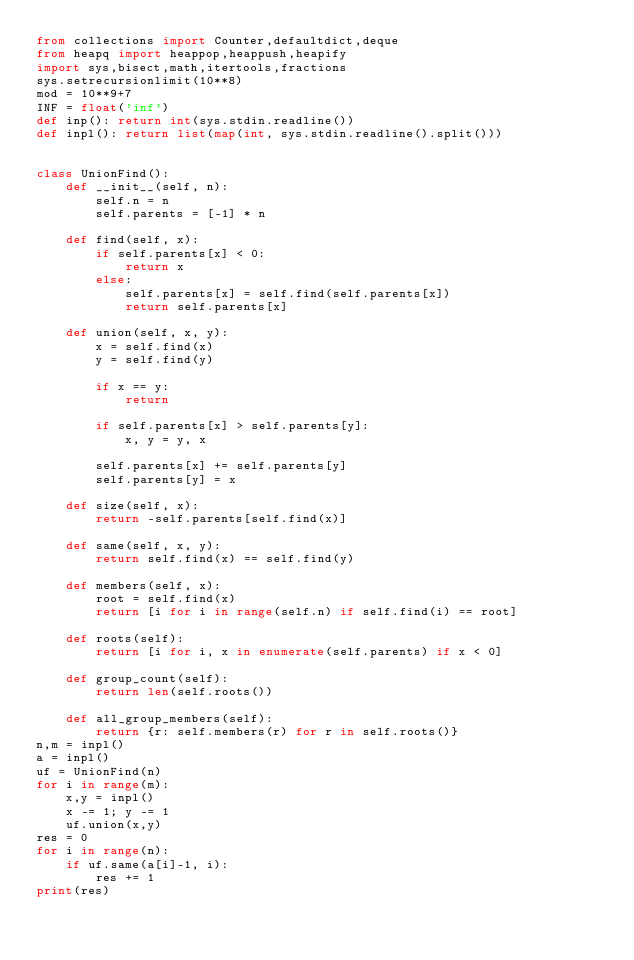<code> <loc_0><loc_0><loc_500><loc_500><_Python_>from collections import Counter,defaultdict,deque
from heapq import heappop,heappush,heapify
import sys,bisect,math,itertools,fractions
sys.setrecursionlimit(10**8)
mod = 10**9+7
INF = float('inf')
def inp(): return int(sys.stdin.readline())
def inpl(): return list(map(int, sys.stdin.readline().split()))


class UnionFind():
    def __init__(self, n):
        self.n = n
        self.parents = [-1] * n

    def find(self, x):
        if self.parents[x] < 0:
            return x
        else:
            self.parents[x] = self.find(self.parents[x])
            return self.parents[x]

    def union(self, x, y):
        x = self.find(x)
        y = self.find(y)

        if x == y:
            return

        if self.parents[x] > self.parents[y]:
            x, y = y, x

        self.parents[x] += self.parents[y]
        self.parents[y] = x

    def size(self, x):
        return -self.parents[self.find(x)]

    def same(self, x, y):
        return self.find(x) == self.find(y)

    def members(self, x):
        root = self.find(x)
        return [i for i in range(self.n) if self.find(i) == root]
        
    def roots(self):
        return [i for i, x in enumerate(self.parents) if x < 0]

    def group_count(self):
        return len(self.roots())
    
    def all_group_members(self):
        return {r: self.members(r) for r in self.roots()}
n,m = inpl()
a = inpl()
uf = UnionFind(n)
for i in range(m):
    x,y = inpl()
    x -= 1; y -= 1
    uf.union(x,y)
res = 0
for i in range(n):
    if uf.same(a[i]-1, i):
        res += 1
print(res)
</code> 